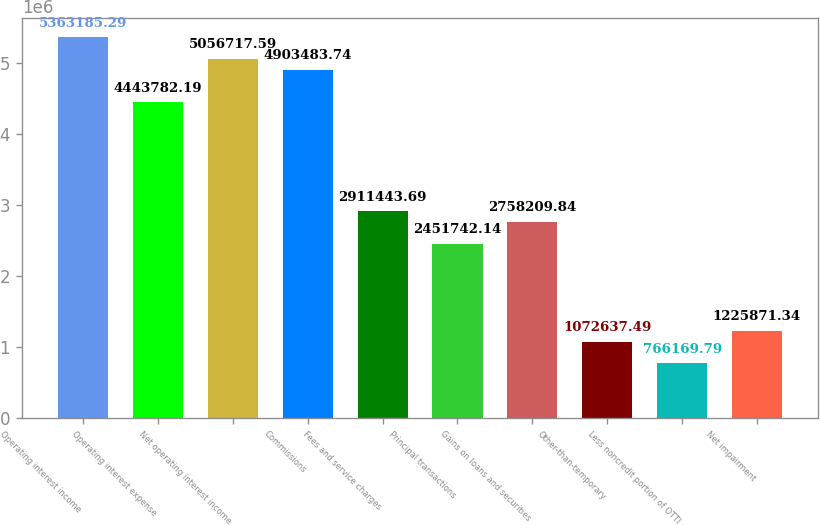<chart> <loc_0><loc_0><loc_500><loc_500><bar_chart><fcel>Operating interest income<fcel>Operating interest expense<fcel>Net operating interest income<fcel>Commissions<fcel>Fees and service charges<fcel>Principal transactions<fcel>Gains on loans and securities<fcel>Other-than-temporary<fcel>Less noncredit portion of OTTI<fcel>Net impairment<nl><fcel>5.36319e+06<fcel>4.44378e+06<fcel>5.05672e+06<fcel>4.90348e+06<fcel>2.91144e+06<fcel>2.45174e+06<fcel>2.75821e+06<fcel>1.07264e+06<fcel>766170<fcel>1.22587e+06<nl></chart> 